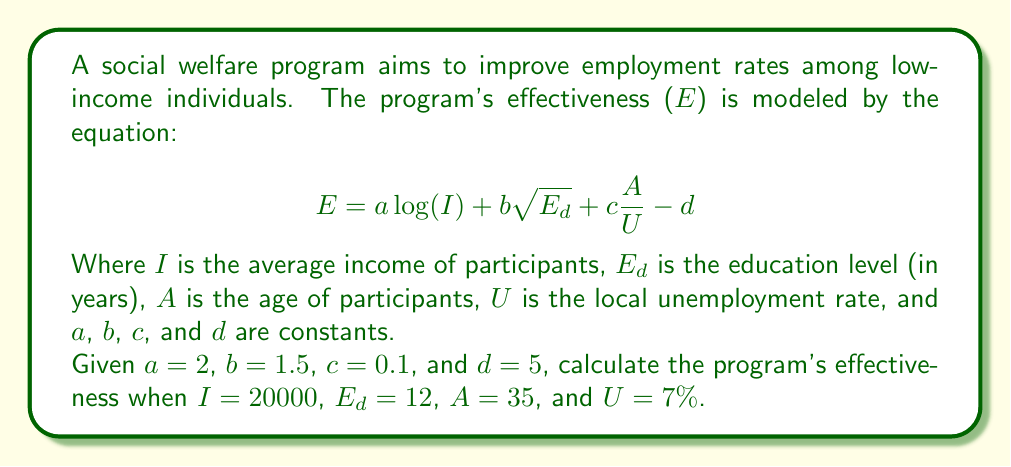Teach me how to tackle this problem. To solve this problem, we'll substitute the given values into the equation and calculate step-by-step:

1) Start with the equation:
   $$E = a\log(I) + b\sqrt{E_d} + c\frac{A}{U} - d$$

2) Substitute the given constants:
   $$E = 2\log(I) + 1.5\sqrt{E_d} + 0.1\frac{A}{U} - 5$$

3) Now, substitute the given values:
   $$E = 2\log(20000) + 1.5\sqrt{12} + 0.1\frac{35}{0.07} - 5$$

4) Calculate $\log(20000)$:
   $\log(20000) \approx 4.30103$

5) Calculate $\sqrt{12}$:
   $\sqrt{12} \approx 3.46410$

6) Calculate $\frac{35}{0.07}$:
   $\frac{35}{0.07} = 500$

7) Now our equation looks like:
   $$E = 2(4.30103) + 1.5(3.46410) + 0.1(500) - 5$$

8) Multiply:
   $$E = 8.60206 + 5.19615 + 50 - 5$$

9) Add all terms:
   $$E = 58.79821$$

10) Round to two decimal places:
    $$E \approx 58.80$$
Answer: 58.80 